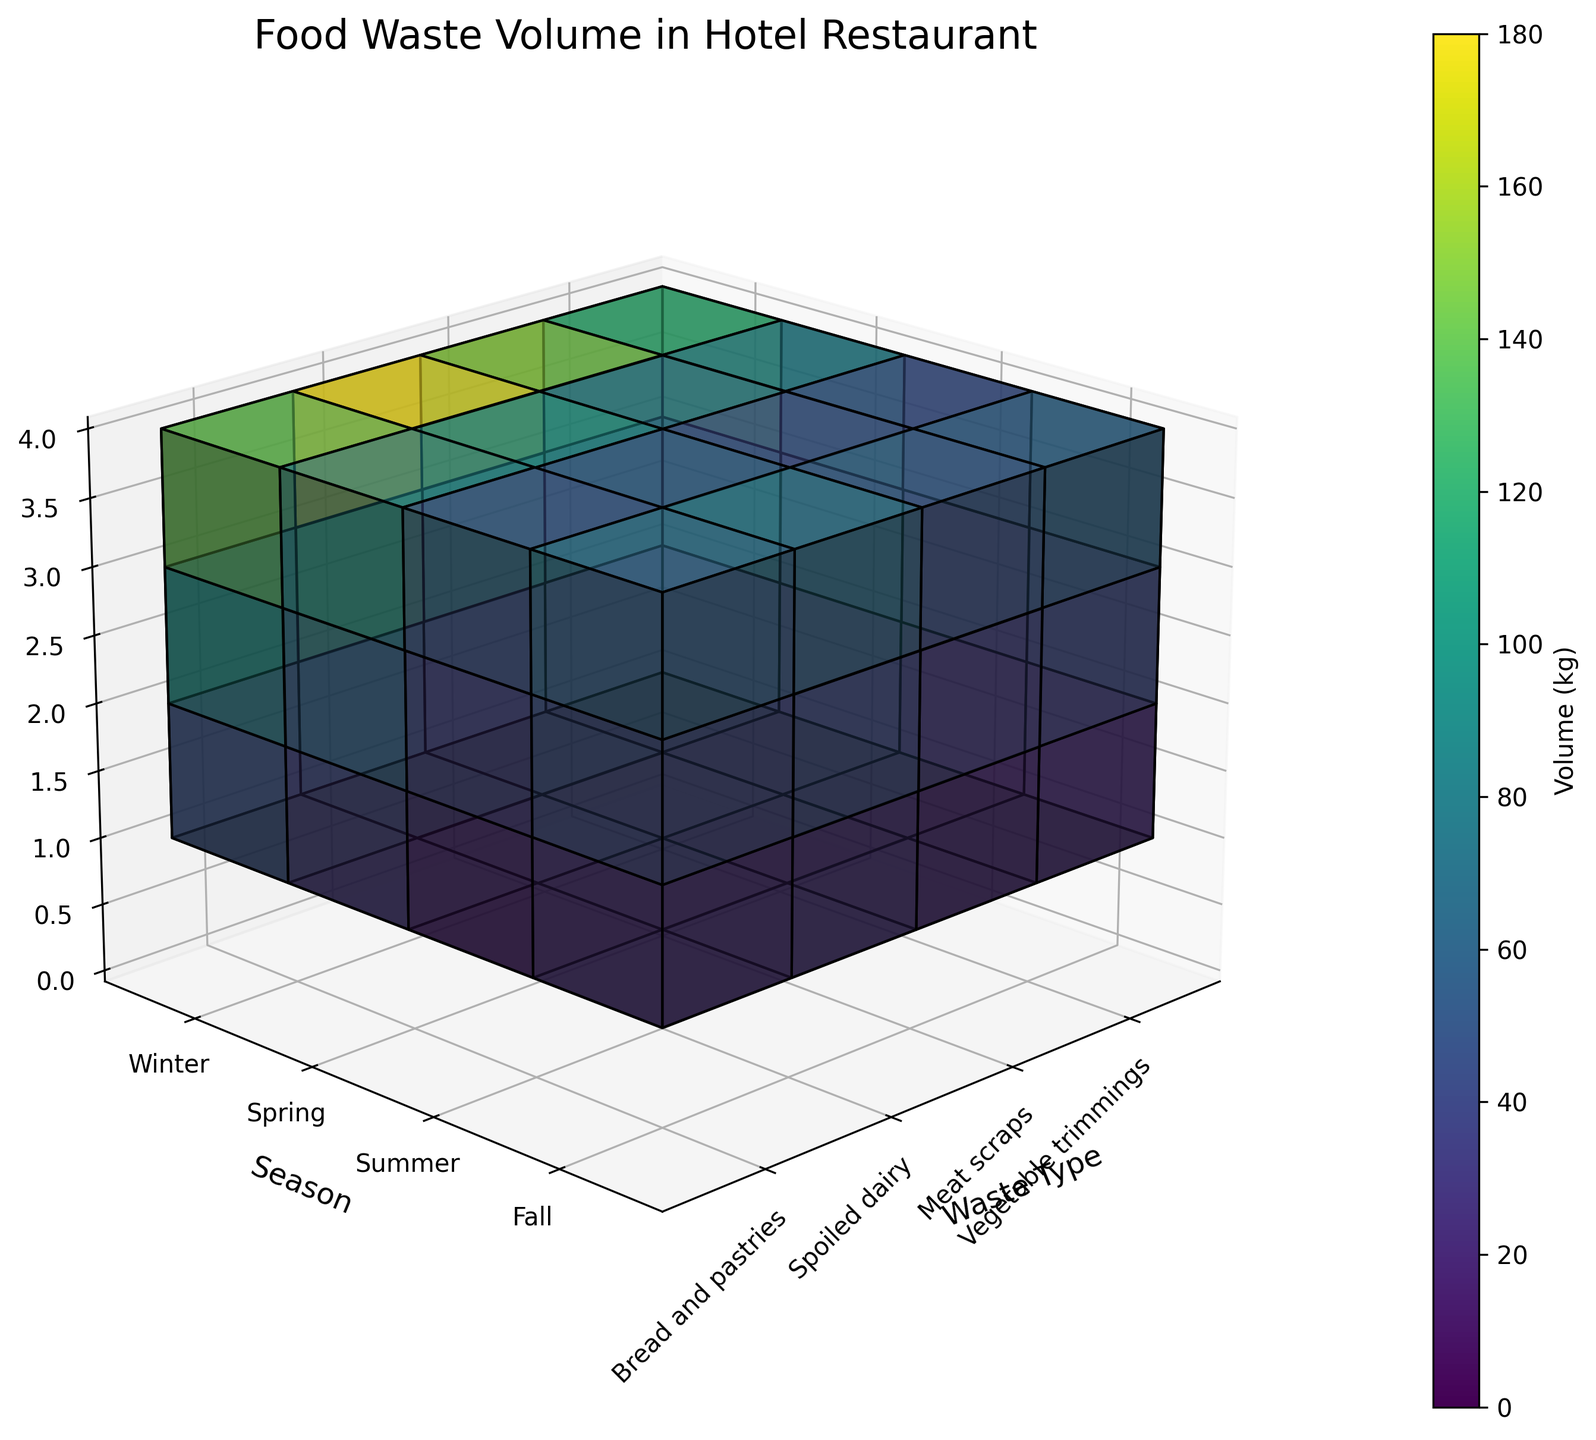what is the title of the figure? The title of the figure is located at the top of the plot and directly indicates what the plot is representing. In this case, it tells us about the food waste volume in the hotel restaurant.
Answer: Food Waste Volume in Hotel Restaurant What season has the highest volume of vegetable trimmings? By examining the height of the voxels for vegetable trimmings across all seasons, the tallest block corresponds to the summer season, indicating the highest volume.
Answer: Summer Which waste type has the lowest volume in spring? To find the lowest volume in spring, look at each waste type for the spring season and compare the heights of the voxels. Spoiled dairy has the shortest block.
Answer: Spoiled dairy By how much does the volume of meat scraps differ between winter and summer? Find the height of the voxels for meat scraps in both winter and summer. Subtract the winter volume (80 kg) from the summer volume (90 kg).
Answer: 10 kg What's the average food waste volume for bread and pastries over all seasons? Sum the volumes of bread and pastries for all four seasons (60 + 55 + 75 + 65) and divide by the number of seasons (4). The total volume is 255 kg, so the average is 255 kg / 4.
Answer: 63.75 kg In which season is the overall food waste volume highest? Examine the combined height of all voxel blocks for each season. Summer has the tallest combined blocks when considering all waste types.
Answer: Summer What is the color associated with the highest food waste volume? The color map typically assigns brighter or darker colors to higher values depending on the scheme. The highest volume (180 kg of vegetable trimmings in summer) corresponds to a specific region on the color bar, likely a deeper hue toward the end of the spectrum.
Answer: Darkest hue (depending on color map) Compare the waste volumes of meat scraps and spoiled dairy in fall. Which is greater and by how much? Look at the heights of voxels for meat scraps and spoiled dairy in fall. Meat scraps (85 kg) have a higher volume compared to spoiled dairy (42 kg). Calculate the difference: 85 kg - 42 kg.
Answer: Meat scraps by 43 kg What's the range of volumes for vegetable trimmings throughout the year? Identify the minimum and maximum waste volumes of vegetable trimmings from all seasons. The range is determined by subtracting the minimum value (120 kg in winter) from the maximum value (180 kg in summer).
Answer: 60 kg Estimate the total food waste volume in spring. Sum the volumes of all waste types in the spring season: 150 (vegetable trimmings) + 70 (meat scraps) + 40 (spoiled dairy) + 55 (bread and pastries).
Answer: 315 kg 